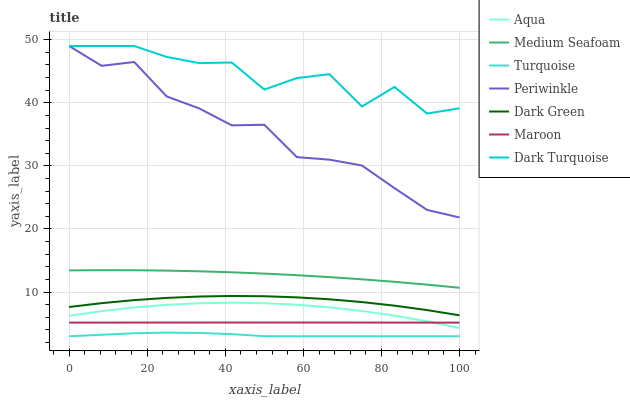Does Turquoise have the minimum area under the curve?
Answer yes or no. Yes. Does Dark Turquoise have the maximum area under the curve?
Answer yes or no. Yes. Does Aqua have the minimum area under the curve?
Answer yes or no. No. Does Aqua have the maximum area under the curve?
Answer yes or no. No. Is Maroon the smoothest?
Answer yes or no. Yes. Is Dark Turquoise the roughest?
Answer yes or no. Yes. Is Aqua the smoothest?
Answer yes or no. No. Is Aqua the roughest?
Answer yes or no. No. Does Turquoise have the lowest value?
Answer yes or no. Yes. Does Aqua have the lowest value?
Answer yes or no. No. Does Periwinkle have the highest value?
Answer yes or no. Yes. Does Aqua have the highest value?
Answer yes or no. No. Is Medium Seafoam less than Periwinkle?
Answer yes or no. Yes. Is Periwinkle greater than Aqua?
Answer yes or no. Yes. Does Dark Turquoise intersect Periwinkle?
Answer yes or no. Yes. Is Dark Turquoise less than Periwinkle?
Answer yes or no. No. Is Dark Turquoise greater than Periwinkle?
Answer yes or no. No. Does Medium Seafoam intersect Periwinkle?
Answer yes or no. No. 